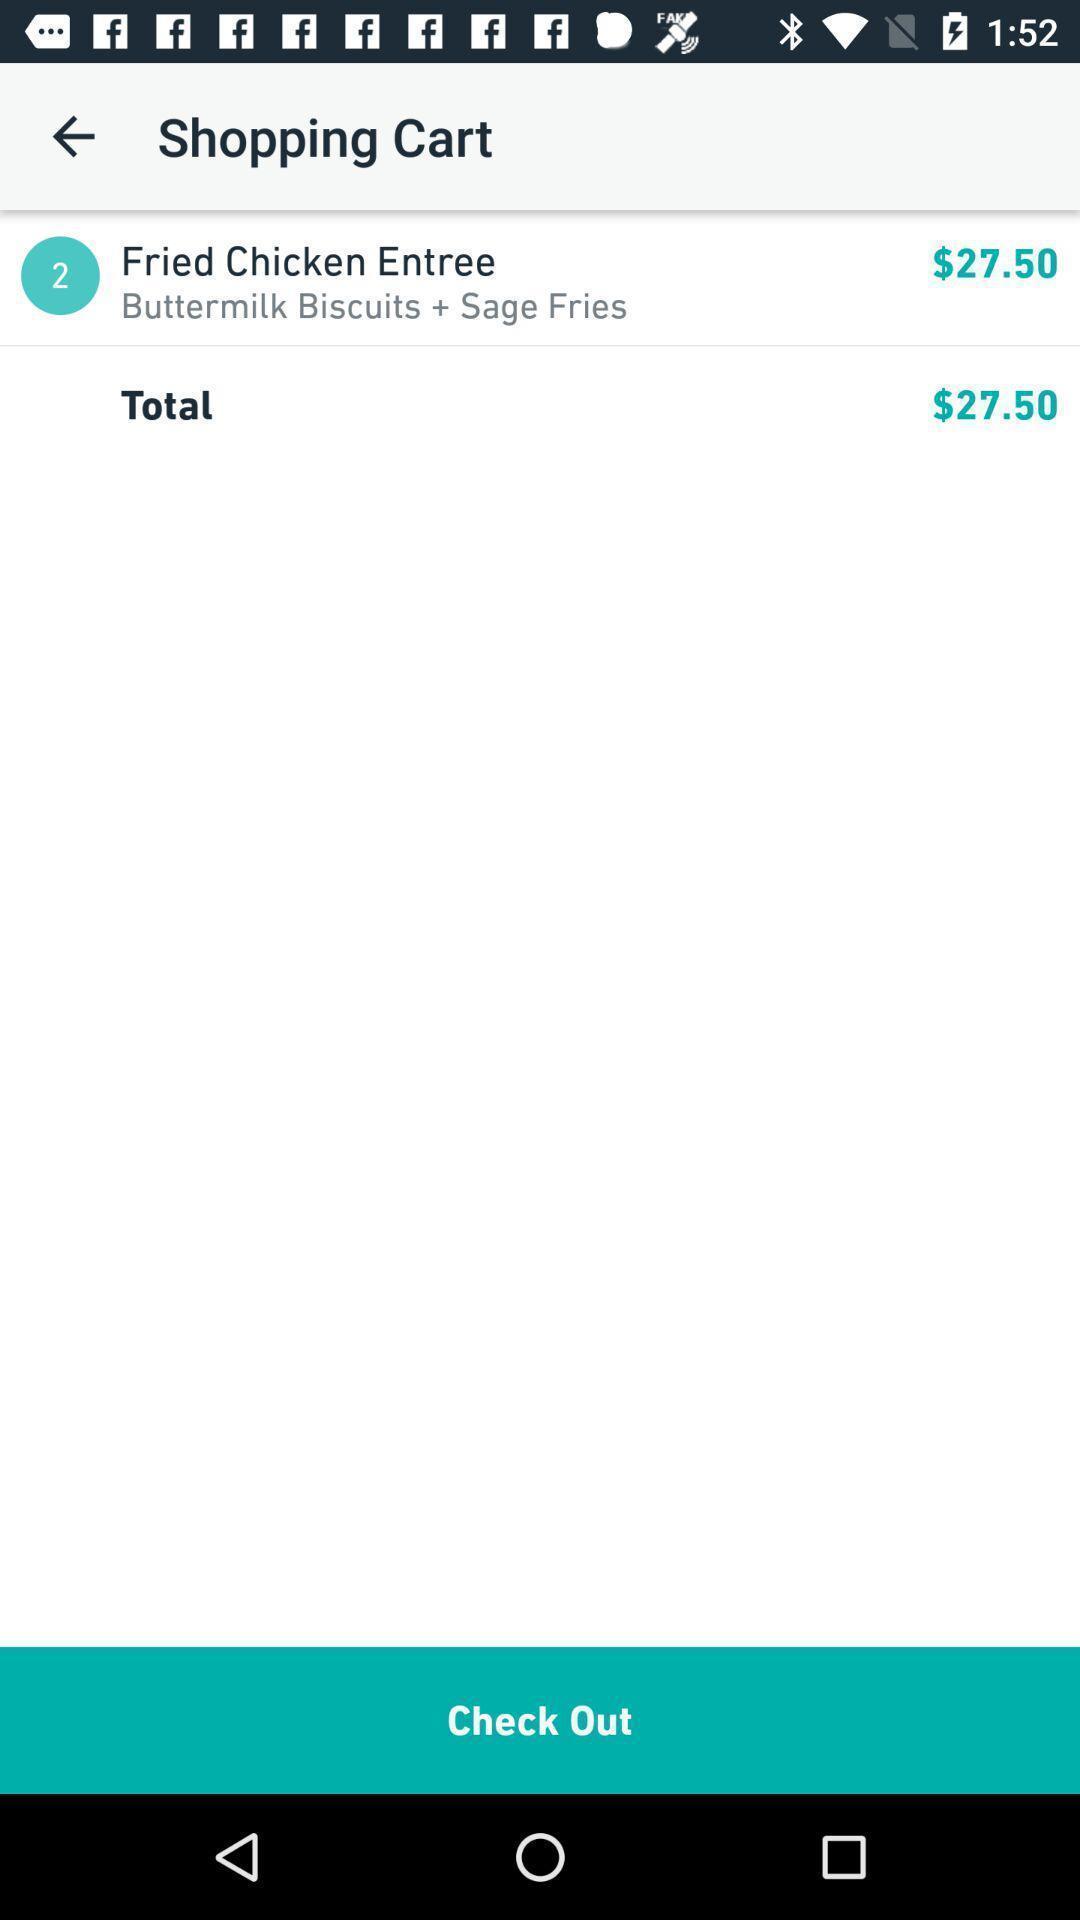Please provide a description for this image. Screen displaying list of items under shopping cart. 